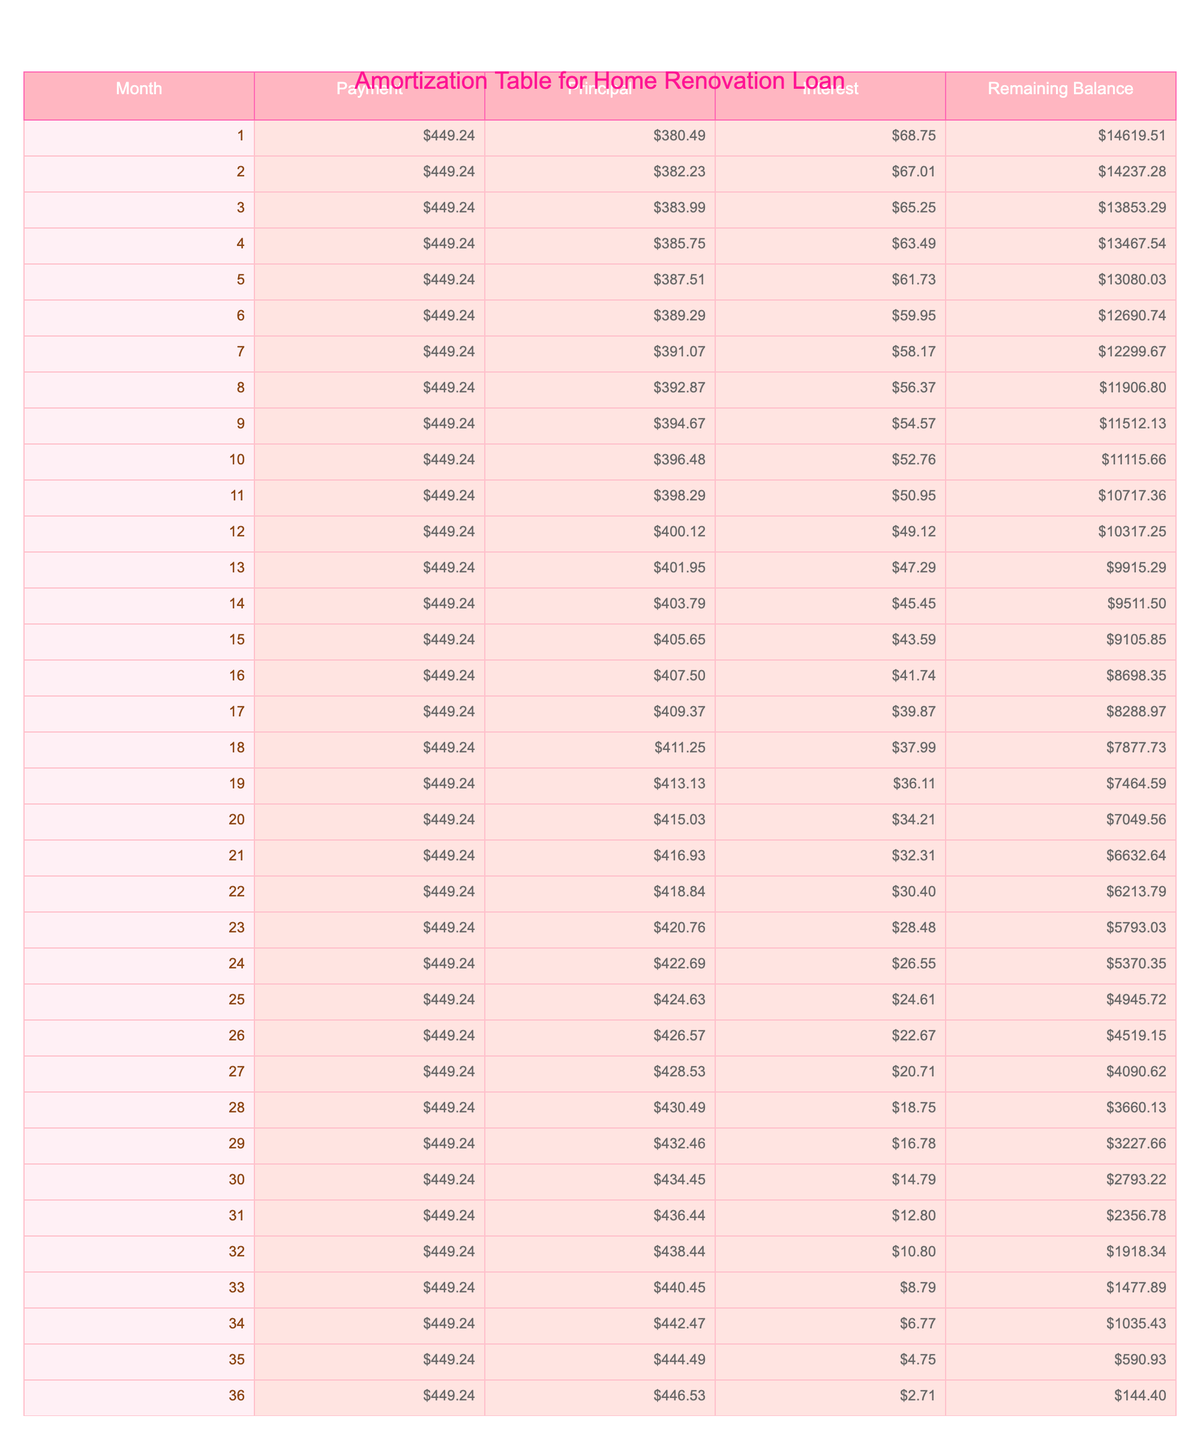What is the total amount paid over the loan term? The total amount paid can be found in the 'Total Payment' column, which shows a value of $16,112.64.
Answer: $16,112.64 What is the monthly repayment amount? The monthly repayment is listed directly in the 'Monthly Repayment' column as $449.24.
Answer: $449.24 How much interest will be paid in total over the life of the loan? The total interest is given in the 'Total Interest' column, which states $1,112.64.
Answer: $1,112.64 During which month is the largest principal payment made? To find the month with the largest principal payment, compare the 'Principal' amounts across all months. After checking the first few months, the principal payment increases as the balance decreases, with the largest observed principal payment in month 1 at $386.24.
Answer: Month 1 What is the remaining balance after 6 months? To find the remaining balance after 6 months, look at the 'Remaining Balance' row for month 6, which shows $8,552.14.
Answer: $8,552.14 Is the monthly payment consistent throughout the loan term? Yes, the monthly payment of $449.24 remains the same for all months according to the table.
Answer: Yes What was the initial loan amount compared to the remaining balance after 12 months? The initial loan amount is $15,000, and referring to the 'Remaining Balance' for month 12 reveals it to be $5,540.44. The difference shows that the remaining balance after 12 months is significantly lower than the initial loan amount.
Answer: Yes, it decreased significantly What is the average interest payment per month over the loan term? Calculate the total interest paid ($1,112.64) and divide by the total number of months (36). This results in an average monthly interest payment of approximately $30.89.
Answer: $30.89 How much of the loan has been repaid after the first 3 months? To determine the total repayment after 3 months, sum the principal payments for those months. For months 1, 2, and 3, they total $386.24, $388.40, and $390.58, respectively, giving a total of $1,165.22.
Answer: $1,165.22 